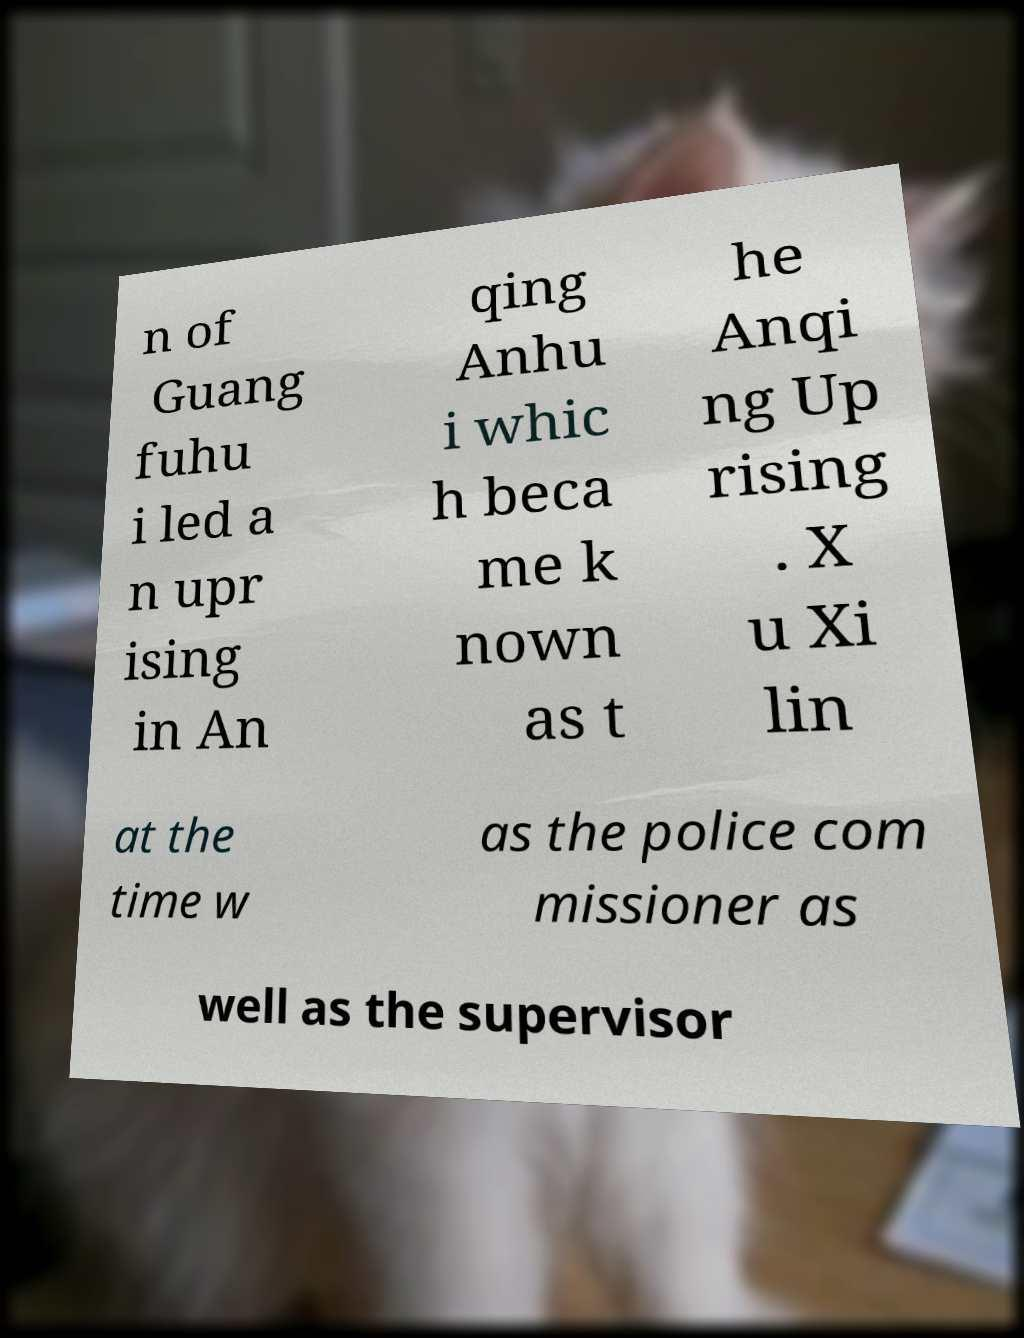For documentation purposes, I need the text within this image transcribed. Could you provide that? n of Guang fuhu i led a n upr ising in An qing Anhu i whic h beca me k nown as t he Anqi ng Up rising . X u Xi lin at the time w as the police com missioner as well as the supervisor 